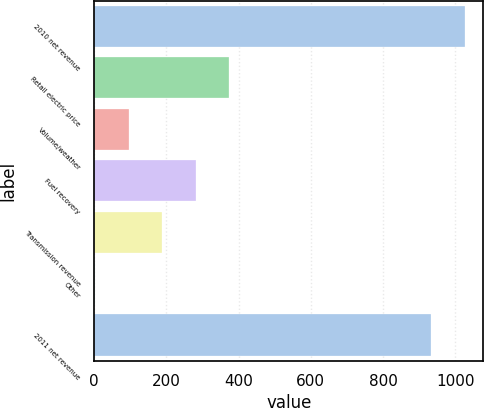<chart> <loc_0><loc_0><loc_500><loc_500><bar_chart><fcel>2010 net revenue<fcel>Retail electric price<fcel>Volume/weather<fcel>Fuel recovery<fcel>Transmission revenue<fcel>Other<fcel>2011 net revenue<nl><fcel>1026.55<fcel>374.7<fcel>95.25<fcel>281.55<fcel>188.4<fcel>2.1<fcel>933.4<nl></chart> 